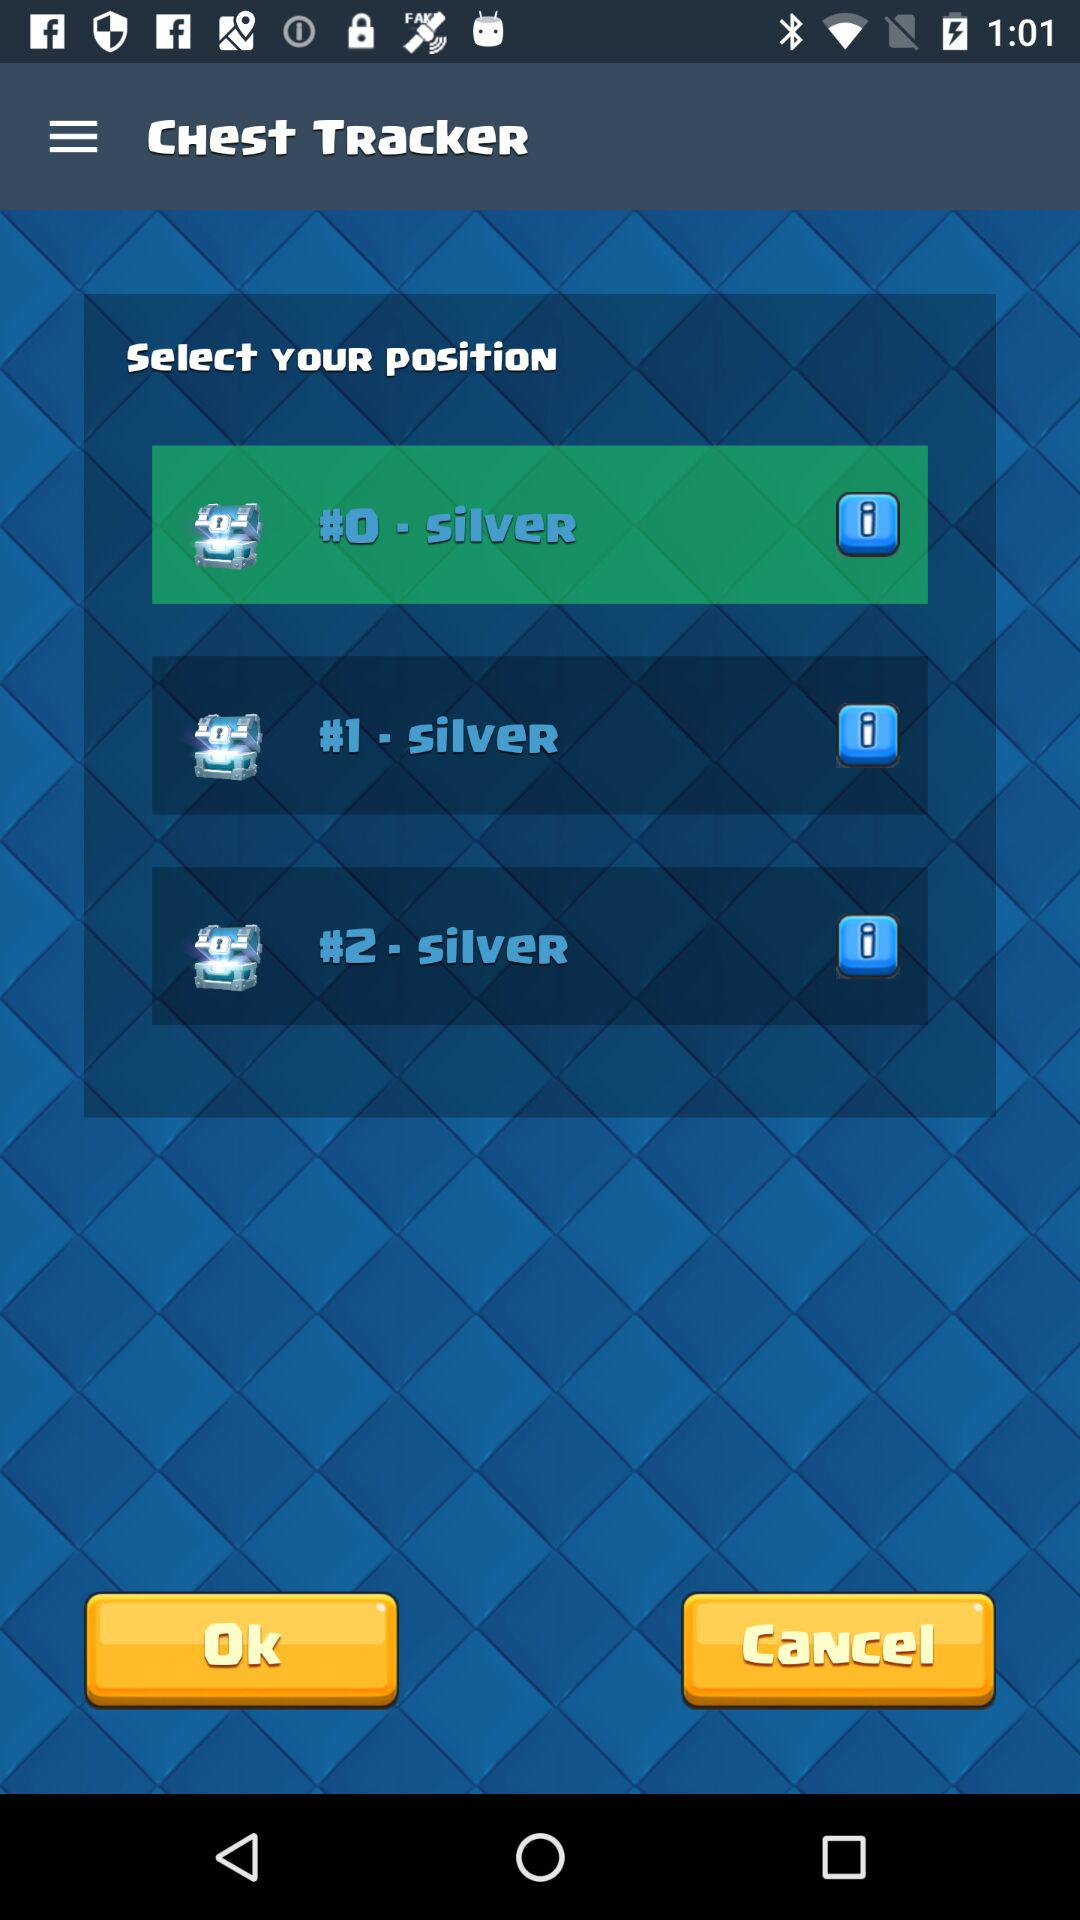How many chests are there?
Answer the question using a single word or phrase. 3 